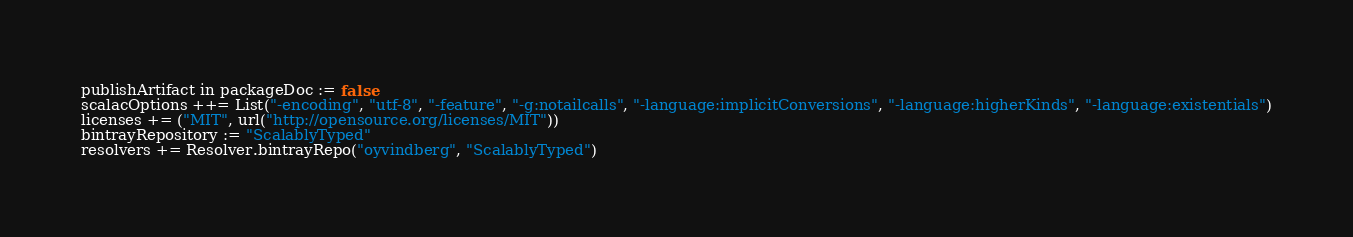Convert code to text. <code><loc_0><loc_0><loc_500><loc_500><_Scala_>publishArtifact in packageDoc := false
scalacOptions ++= List("-encoding", "utf-8", "-feature", "-g:notailcalls", "-language:implicitConversions", "-language:higherKinds", "-language:existentials")
licenses += ("MIT", url("http://opensource.org/licenses/MIT"))
bintrayRepository := "ScalablyTyped"
resolvers += Resolver.bintrayRepo("oyvindberg", "ScalablyTyped")
</code> 